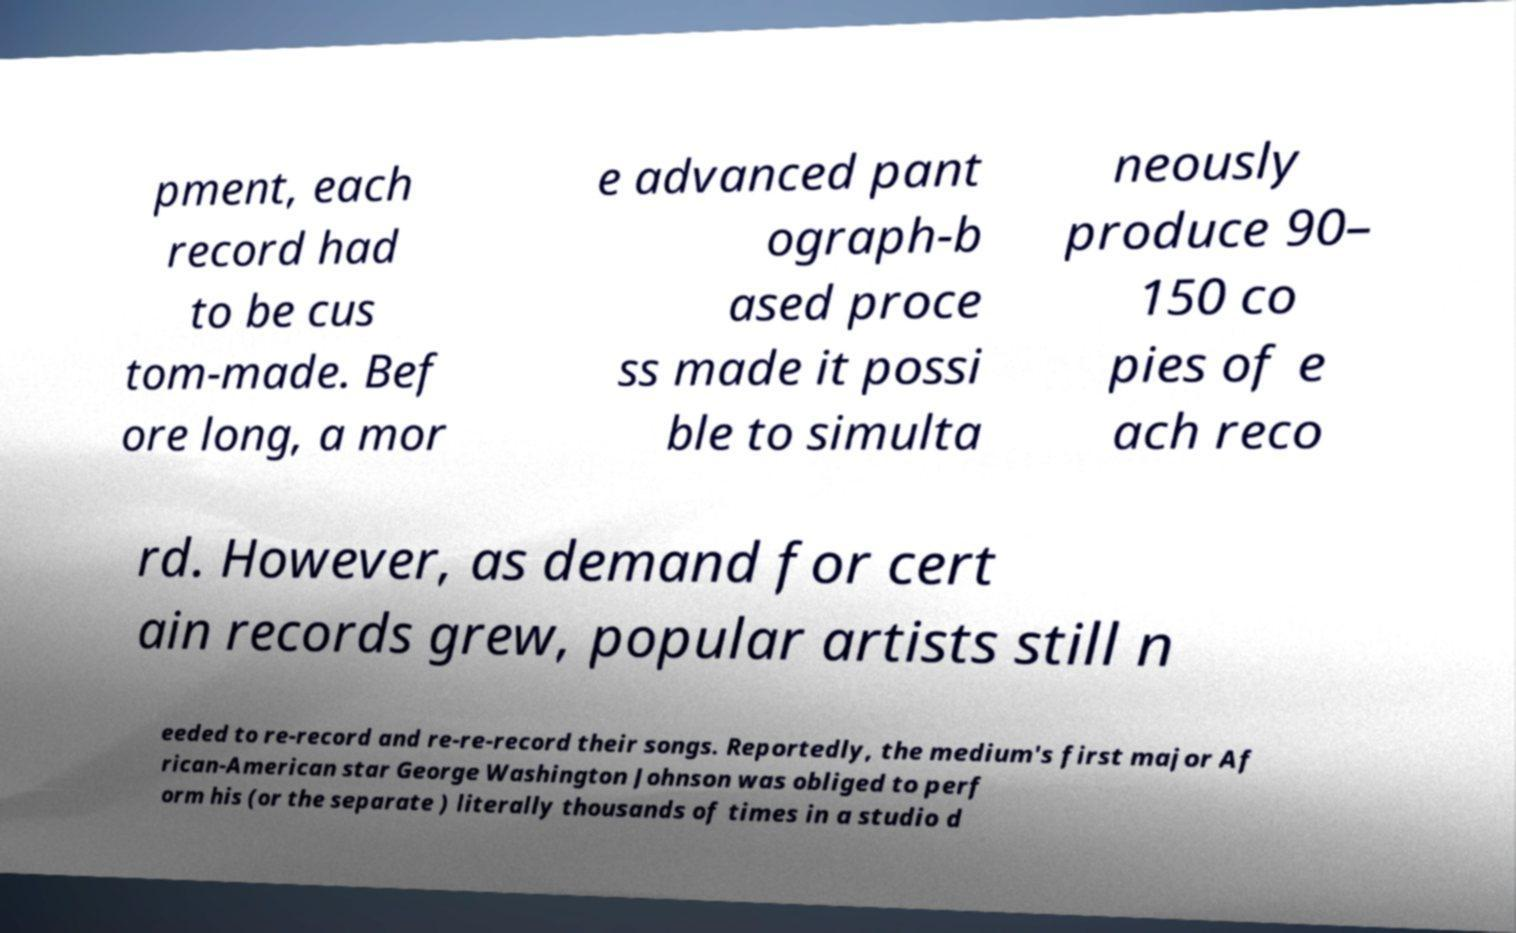For documentation purposes, I need the text within this image transcribed. Could you provide that? pment, each record had to be cus tom-made. Bef ore long, a mor e advanced pant ograph-b ased proce ss made it possi ble to simulta neously produce 90– 150 co pies of e ach reco rd. However, as demand for cert ain records grew, popular artists still n eeded to re-record and re-re-record their songs. Reportedly, the medium's first major Af rican-American star George Washington Johnson was obliged to perf orm his (or the separate ) literally thousands of times in a studio d 